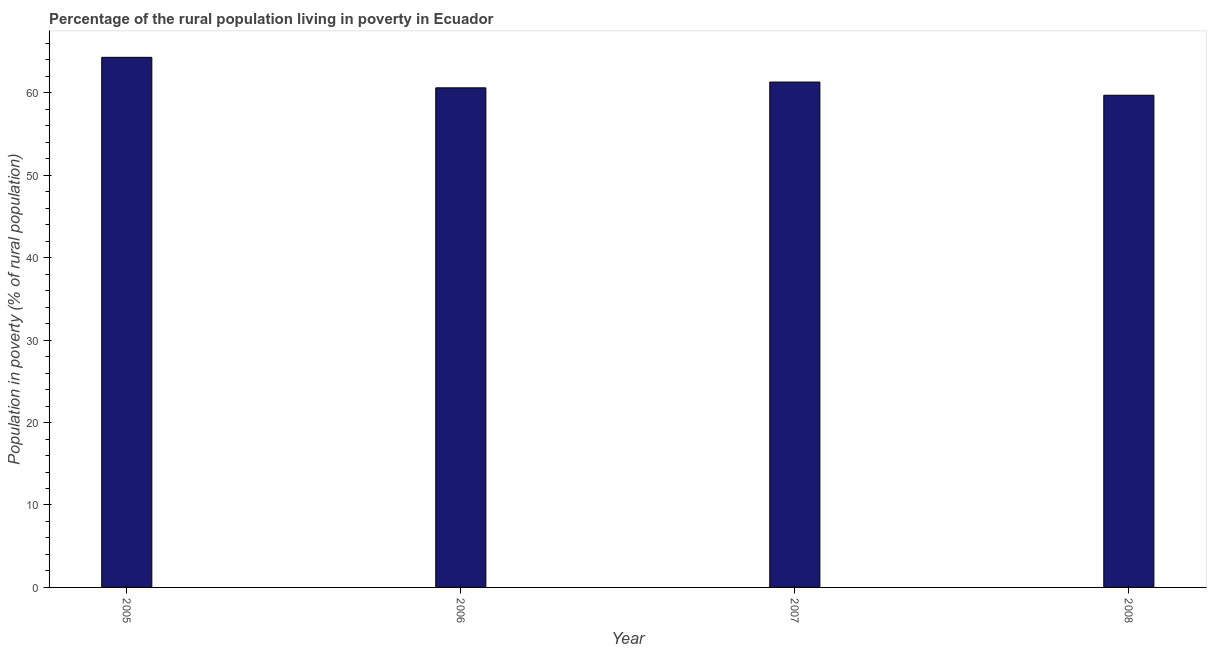Does the graph contain any zero values?
Give a very brief answer. No. What is the title of the graph?
Provide a succinct answer. Percentage of the rural population living in poverty in Ecuador. What is the label or title of the X-axis?
Your response must be concise. Year. What is the label or title of the Y-axis?
Your response must be concise. Population in poverty (% of rural population). What is the percentage of rural population living below poverty line in 2008?
Your answer should be compact. 59.7. Across all years, what is the maximum percentage of rural population living below poverty line?
Your answer should be compact. 64.3. Across all years, what is the minimum percentage of rural population living below poverty line?
Make the answer very short. 59.7. In which year was the percentage of rural population living below poverty line maximum?
Give a very brief answer. 2005. What is the sum of the percentage of rural population living below poverty line?
Your answer should be compact. 245.9. What is the average percentage of rural population living below poverty line per year?
Provide a short and direct response. 61.48. What is the median percentage of rural population living below poverty line?
Offer a terse response. 60.95. Is the percentage of rural population living below poverty line in 2005 less than that in 2007?
Your answer should be compact. No. How many years are there in the graph?
Your response must be concise. 4. Are the values on the major ticks of Y-axis written in scientific E-notation?
Keep it short and to the point. No. What is the Population in poverty (% of rural population) of 2005?
Keep it short and to the point. 64.3. What is the Population in poverty (% of rural population) in 2006?
Your response must be concise. 60.6. What is the Population in poverty (% of rural population) in 2007?
Provide a succinct answer. 61.3. What is the Population in poverty (% of rural population) in 2008?
Your answer should be very brief. 59.7. What is the difference between the Population in poverty (% of rural population) in 2005 and 2006?
Provide a short and direct response. 3.7. What is the difference between the Population in poverty (% of rural population) in 2005 and 2008?
Offer a very short reply. 4.6. What is the difference between the Population in poverty (% of rural population) in 2006 and 2008?
Provide a short and direct response. 0.9. What is the difference between the Population in poverty (% of rural population) in 2007 and 2008?
Provide a short and direct response. 1.6. What is the ratio of the Population in poverty (% of rural population) in 2005 to that in 2006?
Provide a succinct answer. 1.06. What is the ratio of the Population in poverty (% of rural population) in 2005 to that in 2007?
Make the answer very short. 1.05. What is the ratio of the Population in poverty (% of rural population) in 2005 to that in 2008?
Your answer should be compact. 1.08. What is the ratio of the Population in poverty (% of rural population) in 2006 to that in 2008?
Provide a short and direct response. 1.01. 